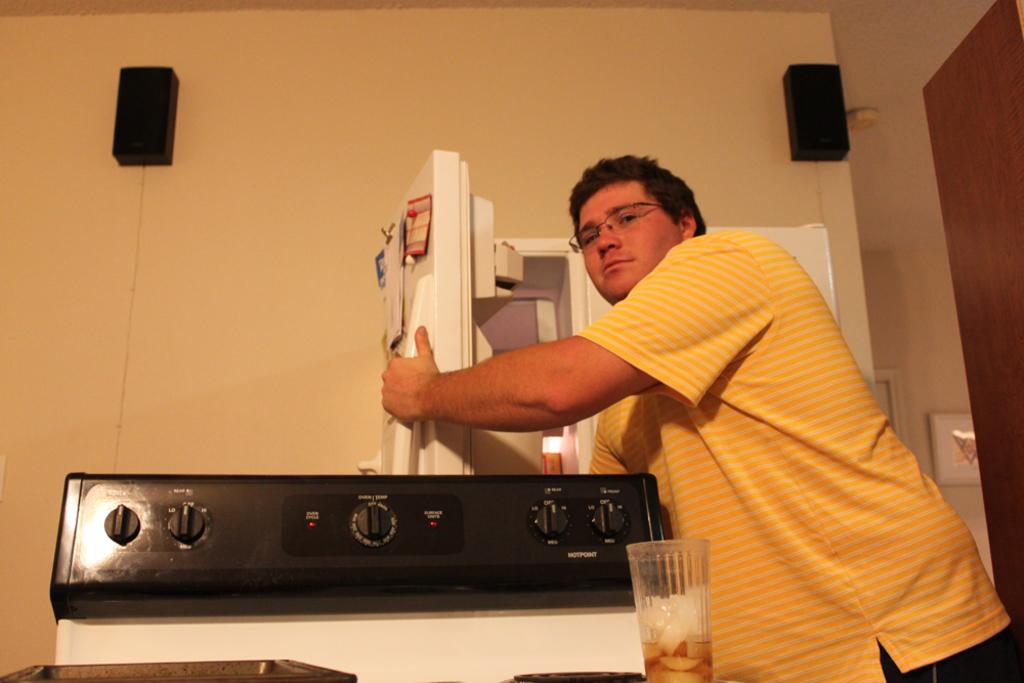Who or what is in the image? There is a person in the image. What is the person holding? The person is holding the handle of a fridge. What can be seen in front of the person? There is a stove in front of the person. What type of audio equipment is present in the image? There are two speakers on the wall. What is the person likely to use for drinking? There is a glass in the image, which the person might use for drinking. What type of decorative item is present in the image? There is a photo frame in the image. How many geese are sitting on the chair in the image? There are no geese or chairs present in the image. What type of comfort does the person in the image experience? The image does not provide information about the person's comfort level. 